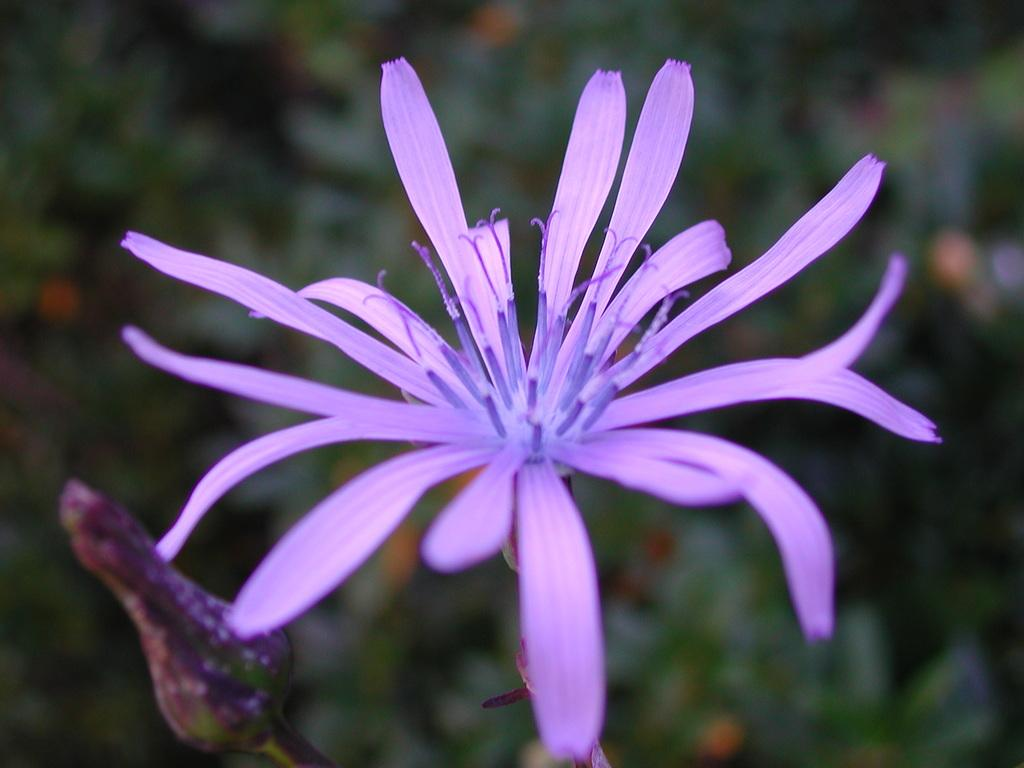What type of flower is present in the image? There is a purple flower in the image. Can you describe the stage of the other flower in the image? There is a flower bud in the image. What color is the background of the flower? The background of the flower is blue. What type of plastic waste can be seen near the flowers in the image? There is no plastic waste present in the image; it only features flowers and a blue background. 